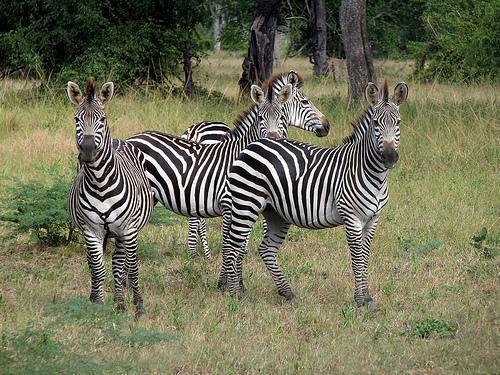How many zebras are facing the right?
Give a very brief answer. 1. How many zebras are in the picture?
Give a very brief answer. 3. How many people are wearing yellow shirt?
Give a very brief answer. 0. 